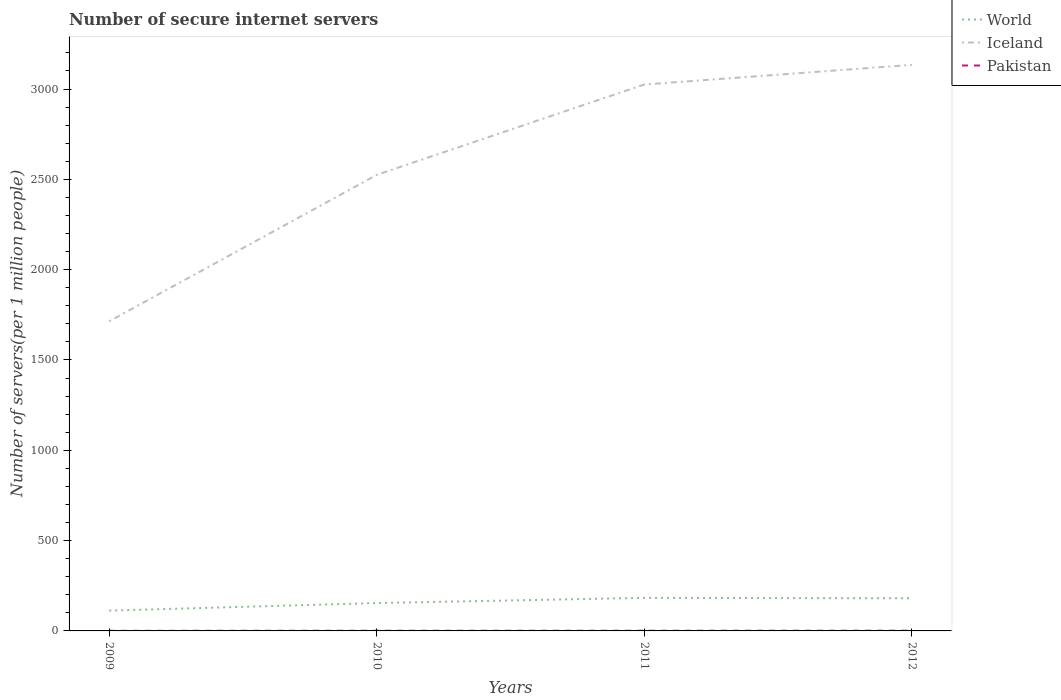Does the line corresponding to World intersect with the line corresponding to Pakistan?
Provide a short and direct response. No. Across all years, what is the maximum number of secure internet servers in Pakistan?
Your answer should be compact. 0.63. What is the total number of secure internet servers in Pakistan in the graph?
Your answer should be compact. -0.15. What is the difference between the highest and the second highest number of secure internet servers in Iceland?
Make the answer very short. 1419.32. Does the graph contain any zero values?
Your answer should be very brief. No. How many legend labels are there?
Ensure brevity in your answer.  3. What is the title of the graph?
Provide a succinct answer. Number of secure internet servers. What is the label or title of the Y-axis?
Ensure brevity in your answer.  Number of servers(per 1 million people). What is the Number of servers(per 1 million people) of World in 2009?
Offer a very short reply. 112.55. What is the Number of servers(per 1 million people) in Iceland in 2009?
Offer a very short reply. 1714.29. What is the Number of servers(per 1 million people) of Pakistan in 2009?
Make the answer very short. 0.63. What is the Number of servers(per 1 million people) in World in 2010?
Keep it short and to the point. 154.27. What is the Number of servers(per 1 million people) of Iceland in 2010?
Offer a terse response. 2524.83. What is the Number of servers(per 1 million people) in Pakistan in 2010?
Offer a terse response. 0.99. What is the Number of servers(per 1 million people) in World in 2011?
Provide a short and direct response. 183.06. What is the Number of servers(per 1 million people) of Iceland in 2011?
Ensure brevity in your answer.  3024.95. What is the Number of servers(per 1 million people) of Pakistan in 2011?
Provide a short and direct response. 1.13. What is the Number of servers(per 1 million people) in World in 2012?
Offer a terse response. 180.71. What is the Number of servers(per 1 million people) of Iceland in 2012?
Ensure brevity in your answer.  3133.61. What is the Number of servers(per 1 million people) of Pakistan in 2012?
Provide a succinct answer. 1.29. Across all years, what is the maximum Number of servers(per 1 million people) of World?
Provide a short and direct response. 183.06. Across all years, what is the maximum Number of servers(per 1 million people) in Iceland?
Provide a short and direct response. 3133.61. Across all years, what is the maximum Number of servers(per 1 million people) in Pakistan?
Ensure brevity in your answer.  1.29. Across all years, what is the minimum Number of servers(per 1 million people) in World?
Your answer should be compact. 112.55. Across all years, what is the minimum Number of servers(per 1 million people) of Iceland?
Your answer should be compact. 1714.29. Across all years, what is the minimum Number of servers(per 1 million people) in Pakistan?
Give a very brief answer. 0.63. What is the total Number of servers(per 1 million people) of World in the graph?
Offer a terse response. 630.59. What is the total Number of servers(per 1 million people) of Iceland in the graph?
Give a very brief answer. 1.04e+04. What is the total Number of servers(per 1 million people) in Pakistan in the graph?
Provide a succinct answer. 4.04. What is the difference between the Number of servers(per 1 million people) in World in 2009 and that in 2010?
Provide a short and direct response. -41.72. What is the difference between the Number of servers(per 1 million people) in Iceland in 2009 and that in 2010?
Provide a succinct answer. -810.54. What is the difference between the Number of servers(per 1 million people) in Pakistan in 2009 and that in 2010?
Your response must be concise. -0.36. What is the difference between the Number of servers(per 1 million people) in World in 2009 and that in 2011?
Offer a very short reply. -70.51. What is the difference between the Number of servers(per 1 million people) of Iceland in 2009 and that in 2011?
Make the answer very short. -1310.65. What is the difference between the Number of servers(per 1 million people) of Pakistan in 2009 and that in 2011?
Offer a terse response. -0.5. What is the difference between the Number of servers(per 1 million people) in World in 2009 and that in 2012?
Offer a very short reply. -68.16. What is the difference between the Number of servers(per 1 million people) in Iceland in 2009 and that in 2012?
Offer a terse response. -1419.32. What is the difference between the Number of servers(per 1 million people) of Pakistan in 2009 and that in 2012?
Provide a short and direct response. -0.65. What is the difference between the Number of servers(per 1 million people) of World in 2010 and that in 2011?
Provide a succinct answer. -28.79. What is the difference between the Number of servers(per 1 million people) in Iceland in 2010 and that in 2011?
Your answer should be very brief. -500.11. What is the difference between the Number of servers(per 1 million people) in Pakistan in 2010 and that in 2011?
Provide a short and direct response. -0.14. What is the difference between the Number of servers(per 1 million people) in World in 2010 and that in 2012?
Provide a short and direct response. -26.45. What is the difference between the Number of servers(per 1 million people) of Iceland in 2010 and that in 2012?
Provide a succinct answer. -608.78. What is the difference between the Number of servers(per 1 million people) of Pakistan in 2010 and that in 2012?
Provide a succinct answer. -0.29. What is the difference between the Number of servers(per 1 million people) of World in 2011 and that in 2012?
Your answer should be compact. 2.35. What is the difference between the Number of servers(per 1 million people) of Iceland in 2011 and that in 2012?
Offer a terse response. -108.67. What is the difference between the Number of servers(per 1 million people) of Pakistan in 2011 and that in 2012?
Provide a succinct answer. -0.15. What is the difference between the Number of servers(per 1 million people) in World in 2009 and the Number of servers(per 1 million people) in Iceland in 2010?
Ensure brevity in your answer.  -2412.28. What is the difference between the Number of servers(per 1 million people) in World in 2009 and the Number of servers(per 1 million people) in Pakistan in 2010?
Make the answer very short. 111.55. What is the difference between the Number of servers(per 1 million people) in Iceland in 2009 and the Number of servers(per 1 million people) in Pakistan in 2010?
Offer a very short reply. 1713.3. What is the difference between the Number of servers(per 1 million people) of World in 2009 and the Number of servers(per 1 million people) of Iceland in 2011?
Make the answer very short. -2912.4. What is the difference between the Number of servers(per 1 million people) in World in 2009 and the Number of servers(per 1 million people) in Pakistan in 2011?
Give a very brief answer. 111.41. What is the difference between the Number of servers(per 1 million people) of Iceland in 2009 and the Number of servers(per 1 million people) of Pakistan in 2011?
Make the answer very short. 1713.16. What is the difference between the Number of servers(per 1 million people) of World in 2009 and the Number of servers(per 1 million people) of Iceland in 2012?
Your answer should be very brief. -3021.07. What is the difference between the Number of servers(per 1 million people) in World in 2009 and the Number of servers(per 1 million people) in Pakistan in 2012?
Make the answer very short. 111.26. What is the difference between the Number of servers(per 1 million people) in Iceland in 2009 and the Number of servers(per 1 million people) in Pakistan in 2012?
Your response must be concise. 1713.01. What is the difference between the Number of servers(per 1 million people) in World in 2010 and the Number of servers(per 1 million people) in Iceland in 2011?
Provide a succinct answer. -2870.68. What is the difference between the Number of servers(per 1 million people) of World in 2010 and the Number of servers(per 1 million people) of Pakistan in 2011?
Your answer should be compact. 153.13. What is the difference between the Number of servers(per 1 million people) of Iceland in 2010 and the Number of servers(per 1 million people) of Pakistan in 2011?
Provide a short and direct response. 2523.7. What is the difference between the Number of servers(per 1 million people) of World in 2010 and the Number of servers(per 1 million people) of Iceland in 2012?
Keep it short and to the point. -2979.35. What is the difference between the Number of servers(per 1 million people) of World in 2010 and the Number of servers(per 1 million people) of Pakistan in 2012?
Your answer should be compact. 152.98. What is the difference between the Number of servers(per 1 million people) of Iceland in 2010 and the Number of servers(per 1 million people) of Pakistan in 2012?
Provide a succinct answer. 2523.55. What is the difference between the Number of servers(per 1 million people) of World in 2011 and the Number of servers(per 1 million people) of Iceland in 2012?
Your response must be concise. -2950.55. What is the difference between the Number of servers(per 1 million people) of World in 2011 and the Number of servers(per 1 million people) of Pakistan in 2012?
Provide a short and direct response. 181.78. What is the difference between the Number of servers(per 1 million people) in Iceland in 2011 and the Number of servers(per 1 million people) in Pakistan in 2012?
Offer a terse response. 3023.66. What is the average Number of servers(per 1 million people) of World per year?
Make the answer very short. 157.65. What is the average Number of servers(per 1 million people) in Iceland per year?
Your response must be concise. 2599.42. What is the average Number of servers(per 1 million people) in Pakistan per year?
Ensure brevity in your answer.  1.01. In the year 2009, what is the difference between the Number of servers(per 1 million people) of World and Number of servers(per 1 million people) of Iceland?
Make the answer very short. -1601.74. In the year 2009, what is the difference between the Number of servers(per 1 million people) of World and Number of servers(per 1 million people) of Pakistan?
Your answer should be compact. 111.92. In the year 2009, what is the difference between the Number of servers(per 1 million people) in Iceland and Number of servers(per 1 million people) in Pakistan?
Keep it short and to the point. 1713.66. In the year 2010, what is the difference between the Number of servers(per 1 million people) of World and Number of servers(per 1 million people) of Iceland?
Keep it short and to the point. -2370.57. In the year 2010, what is the difference between the Number of servers(per 1 million people) of World and Number of servers(per 1 million people) of Pakistan?
Make the answer very short. 153.27. In the year 2010, what is the difference between the Number of servers(per 1 million people) of Iceland and Number of servers(per 1 million people) of Pakistan?
Make the answer very short. 2523.84. In the year 2011, what is the difference between the Number of servers(per 1 million people) in World and Number of servers(per 1 million people) in Iceland?
Make the answer very short. -2841.88. In the year 2011, what is the difference between the Number of servers(per 1 million people) in World and Number of servers(per 1 million people) in Pakistan?
Your answer should be compact. 181.93. In the year 2011, what is the difference between the Number of servers(per 1 million people) of Iceland and Number of servers(per 1 million people) of Pakistan?
Ensure brevity in your answer.  3023.81. In the year 2012, what is the difference between the Number of servers(per 1 million people) of World and Number of servers(per 1 million people) of Iceland?
Provide a succinct answer. -2952.9. In the year 2012, what is the difference between the Number of servers(per 1 million people) in World and Number of servers(per 1 million people) in Pakistan?
Offer a very short reply. 179.43. In the year 2012, what is the difference between the Number of servers(per 1 million people) in Iceland and Number of servers(per 1 million people) in Pakistan?
Give a very brief answer. 3132.33. What is the ratio of the Number of servers(per 1 million people) in World in 2009 to that in 2010?
Keep it short and to the point. 0.73. What is the ratio of the Number of servers(per 1 million people) in Iceland in 2009 to that in 2010?
Ensure brevity in your answer.  0.68. What is the ratio of the Number of servers(per 1 million people) in Pakistan in 2009 to that in 2010?
Make the answer very short. 0.63. What is the ratio of the Number of servers(per 1 million people) in World in 2009 to that in 2011?
Offer a terse response. 0.61. What is the ratio of the Number of servers(per 1 million people) of Iceland in 2009 to that in 2011?
Make the answer very short. 0.57. What is the ratio of the Number of servers(per 1 million people) of Pakistan in 2009 to that in 2011?
Ensure brevity in your answer.  0.56. What is the ratio of the Number of servers(per 1 million people) in World in 2009 to that in 2012?
Your response must be concise. 0.62. What is the ratio of the Number of servers(per 1 million people) of Iceland in 2009 to that in 2012?
Provide a succinct answer. 0.55. What is the ratio of the Number of servers(per 1 million people) of Pakistan in 2009 to that in 2012?
Make the answer very short. 0.49. What is the ratio of the Number of servers(per 1 million people) of World in 2010 to that in 2011?
Offer a very short reply. 0.84. What is the ratio of the Number of servers(per 1 million people) of Iceland in 2010 to that in 2011?
Ensure brevity in your answer.  0.83. What is the ratio of the Number of servers(per 1 million people) of Pakistan in 2010 to that in 2011?
Ensure brevity in your answer.  0.88. What is the ratio of the Number of servers(per 1 million people) of World in 2010 to that in 2012?
Offer a very short reply. 0.85. What is the ratio of the Number of servers(per 1 million people) of Iceland in 2010 to that in 2012?
Keep it short and to the point. 0.81. What is the ratio of the Number of servers(per 1 million people) in Pakistan in 2010 to that in 2012?
Your answer should be compact. 0.77. What is the ratio of the Number of servers(per 1 million people) in World in 2011 to that in 2012?
Your answer should be very brief. 1.01. What is the ratio of the Number of servers(per 1 million people) in Iceland in 2011 to that in 2012?
Offer a terse response. 0.97. What is the ratio of the Number of servers(per 1 million people) of Pakistan in 2011 to that in 2012?
Provide a succinct answer. 0.88. What is the difference between the highest and the second highest Number of servers(per 1 million people) of World?
Your answer should be compact. 2.35. What is the difference between the highest and the second highest Number of servers(per 1 million people) of Iceland?
Give a very brief answer. 108.67. What is the difference between the highest and the second highest Number of servers(per 1 million people) of Pakistan?
Provide a succinct answer. 0.15. What is the difference between the highest and the lowest Number of servers(per 1 million people) in World?
Provide a short and direct response. 70.51. What is the difference between the highest and the lowest Number of servers(per 1 million people) in Iceland?
Offer a terse response. 1419.32. What is the difference between the highest and the lowest Number of servers(per 1 million people) of Pakistan?
Ensure brevity in your answer.  0.65. 